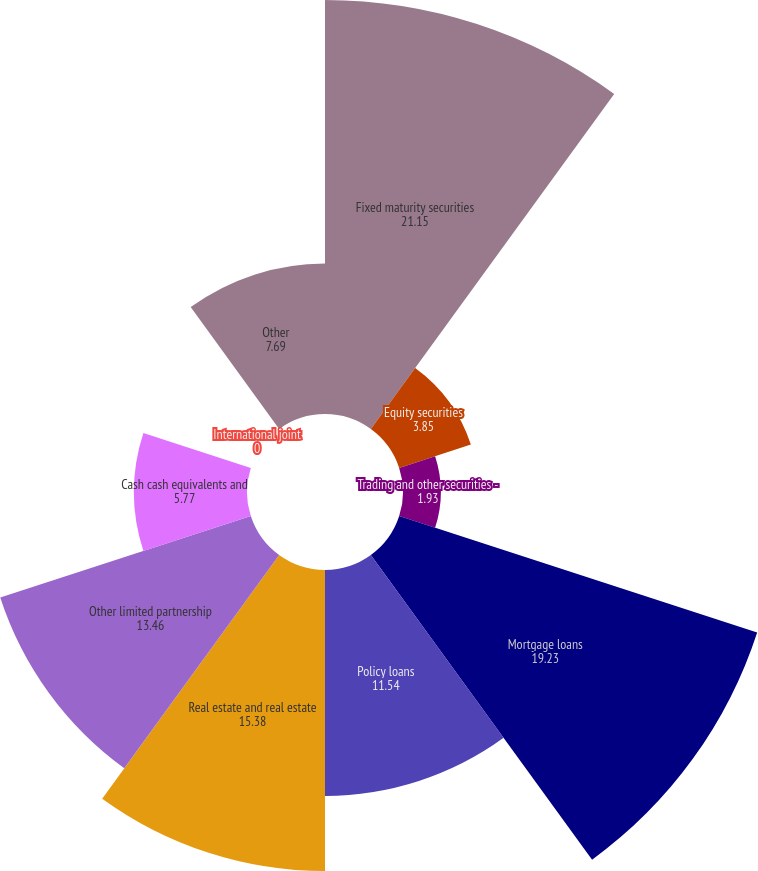Convert chart to OTSL. <chart><loc_0><loc_0><loc_500><loc_500><pie_chart><fcel>Fixed maturity securities<fcel>Equity securities<fcel>Trading and other securities -<fcel>Mortgage loans<fcel>Policy loans<fcel>Real estate and real estate<fcel>Other limited partnership<fcel>Cash cash equivalents and<fcel>International joint<fcel>Other<nl><fcel>21.15%<fcel>3.85%<fcel>1.93%<fcel>19.23%<fcel>11.54%<fcel>15.38%<fcel>13.46%<fcel>5.77%<fcel>0.0%<fcel>7.69%<nl></chart> 